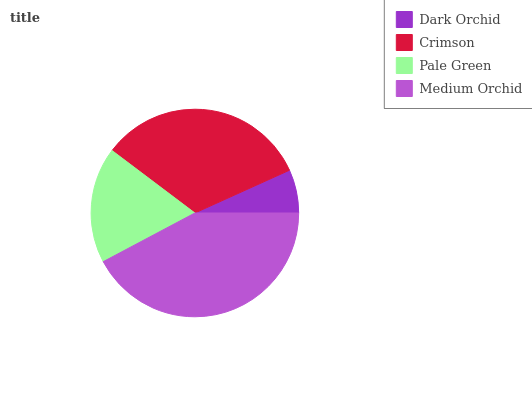Is Dark Orchid the minimum?
Answer yes or no. Yes. Is Medium Orchid the maximum?
Answer yes or no. Yes. Is Crimson the minimum?
Answer yes or no. No. Is Crimson the maximum?
Answer yes or no. No. Is Crimson greater than Dark Orchid?
Answer yes or no. Yes. Is Dark Orchid less than Crimson?
Answer yes or no. Yes. Is Dark Orchid greater than Crimson?
Answer yes or no. No. Is Crimson less than Dark Orchid?
Answer yes or no. No. Is Crimson the high median?
Answer yes or no. Yes. Is Pale Green the low median?
Answer yes or no. Yes. Is Dark Orchid the high median?
Answer yes or no. No. Is Medium Orchid the low median?
Answer yes or no. No. 